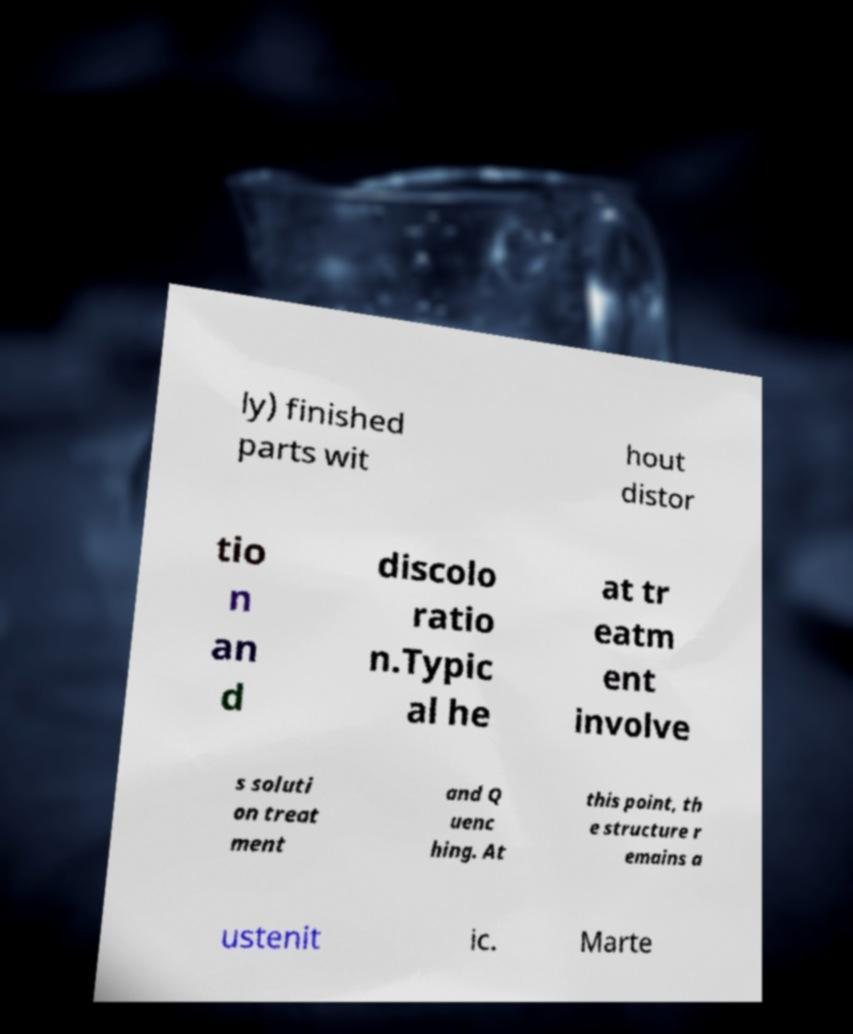What messages or text are displayed in this image? I need them in a readable, typed format. ly) finished parts wit hout distor tio n an d discolo ratio n.Typic al he at tr eatm ent involve s soluti on treat ment and Q uenc hing. At this point, th e structure r emains a ustenit ic. Marte 